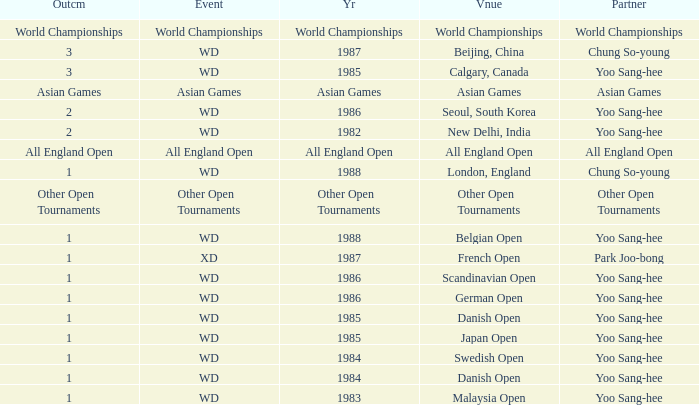What was the Outcome of the Danish Open in 1985? 1.0. 